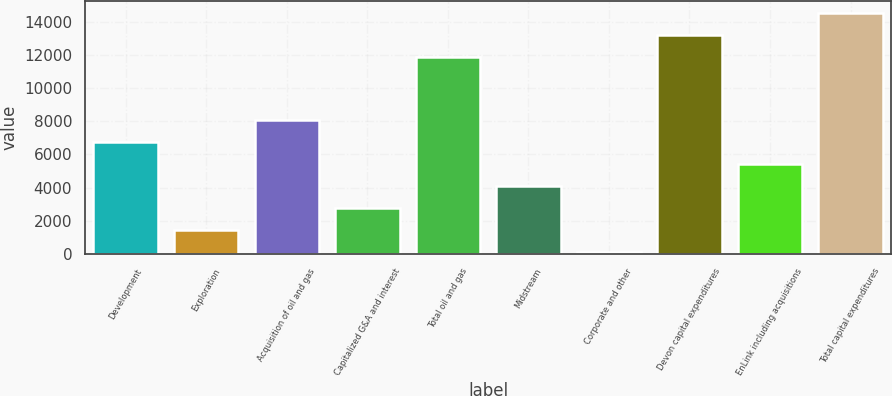Convert chart to OTSL. <chart><loc_0><loc_0><loc_500><loc_500><bar_chart><fcel>Development<fcel>Exploration<fcel>Acquisition of oil and gas<fcel>Capitalized G&A and interest<fcel>Total oil and gas<fcel>Midstream<fcel>Corporate and other<fcel>Devon capital expenditures<fcel>EnLink including acquisitions<fcel>Total capital expenditures<nl><fcel>6779.5<fcel>1443.1<fcel>8113.6<fcel>2777.2<fcel>11914<fcel>4111.3<fcel>109<fcel>13248.1<fcel>5445.4<fcel>14582.2<nl></chart> 